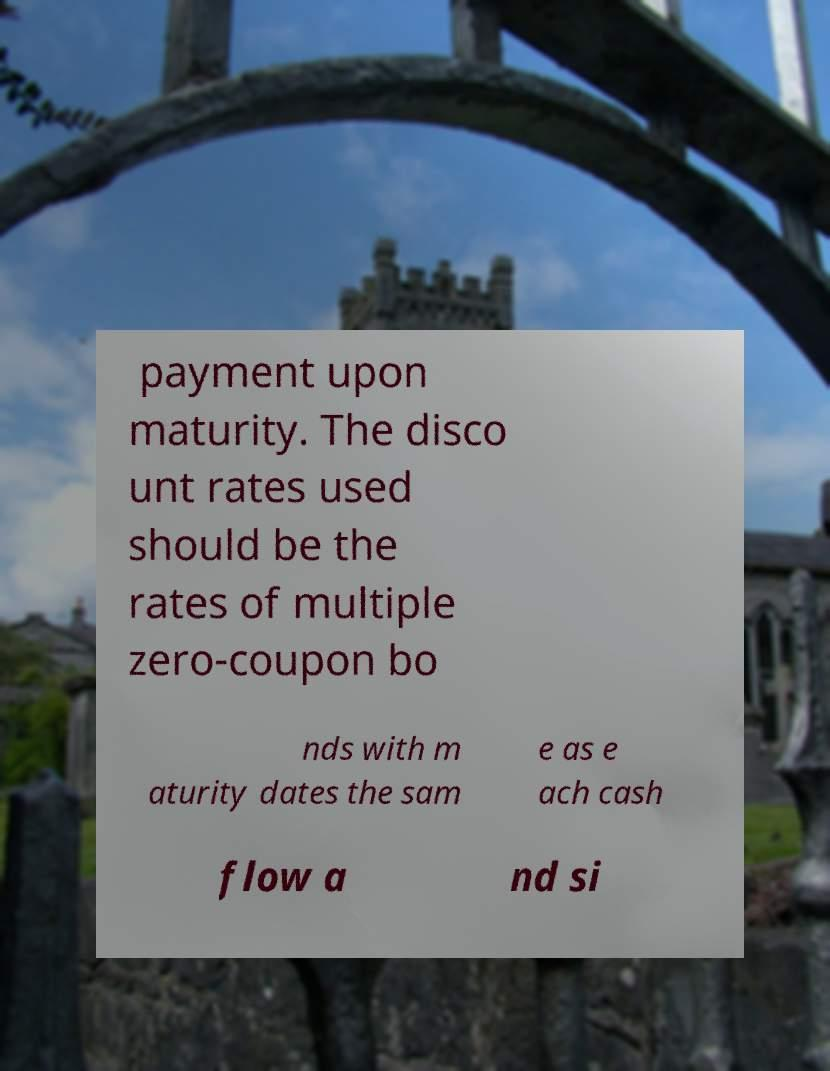Could you assist in decoding the text presented in this image and type it out clearly? payment upon maturity. The disco unt rates used should be the rates of multiple zero-coupon bo nds with m aturity dates the sam e as e ach cash flow a nd si 